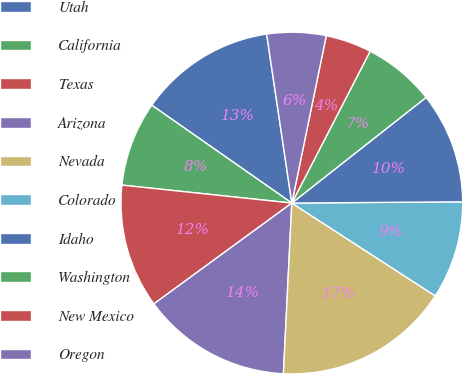Convert chart to OTSL. <chart><loc_0><loc_0><loc_500><loc_500><pie_chart><fcel>Utah<fcel>California<fcel>Texas<fcel>Arizona<fcel>Nevada<fcel>Colorado<fcel>Idaho<fcel>Washington<fcel>New Mexico<fcel>Oregon<nl><fcel>12.94%<fcel>8.03%<fcel>11.72%<fcel>14.17%<fcel>16.64%<fcel>9.26%<fcel>10.49%<fcel>6.81%<fcel>4.35%<fcel>5.58%<nl></chart> 